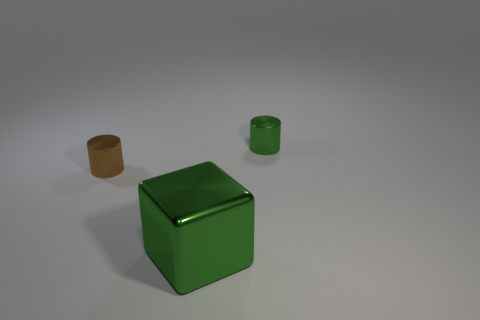Add 1 small green objects. How many objects exist? 4 Subtract all cylinders. How many objects are left? 1 Subtract all tiny cyan cylinders. Subtract all small green shiny cylinders. How many objects are left? 2 Add 2 large green metallic cubes. How many large green metallic cubes are left? 3 Add 3 tiny cylinders. How many tiny cylinders exist? 5 Subtract 0 red blocks. How many objects are left? 3 Subtract 1 cylinders. How many cylinders are left? 1 Subtract all gray cubes. Subtract all purple cylinders. How many cubes are left? 1 